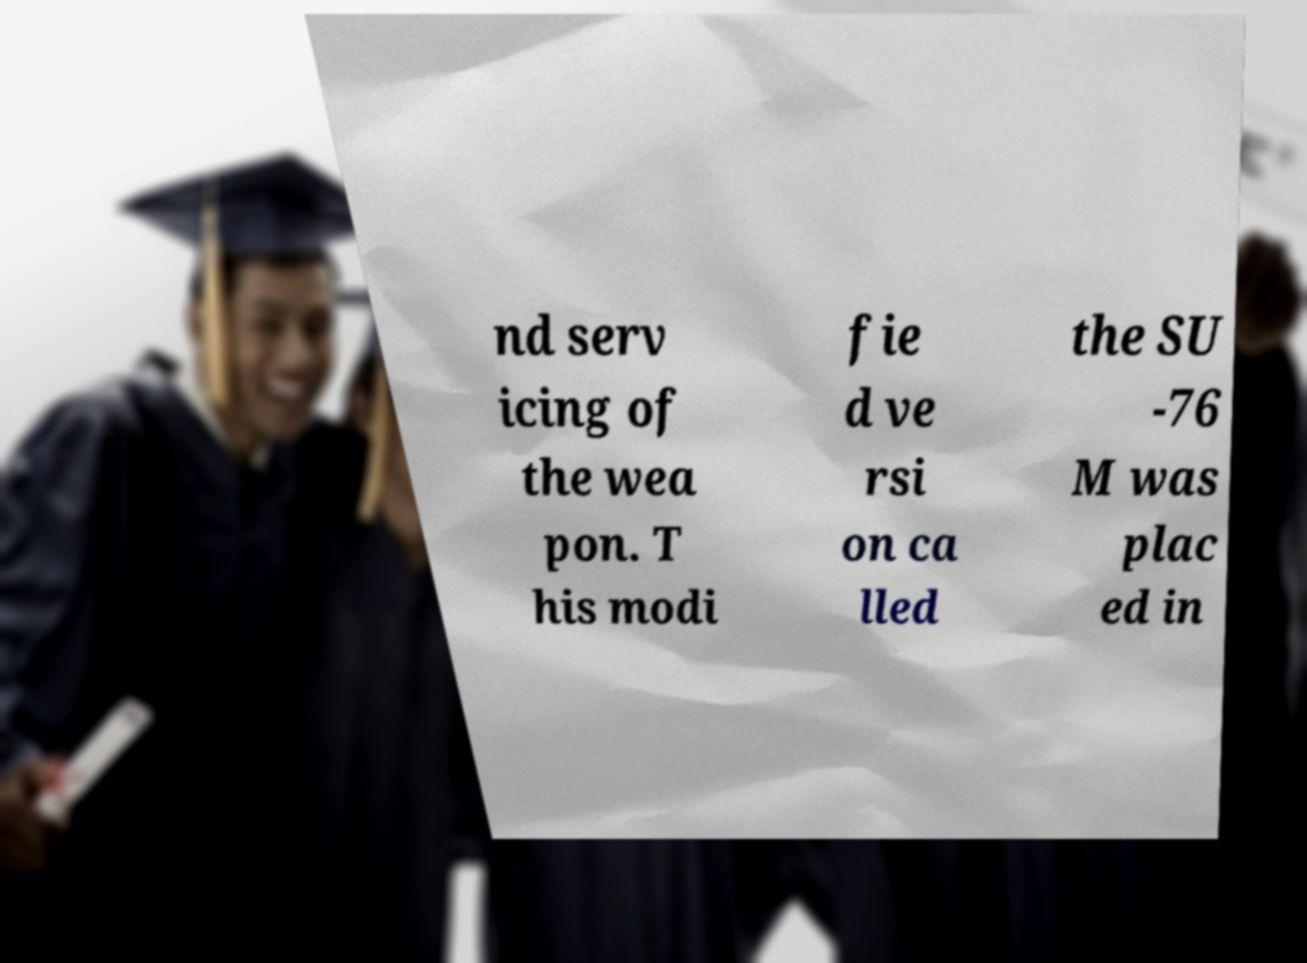I need the written content from this picture converted into text. Can you do that? nd serv icing of the wea pon. T his modi fie d ve rsi on ca lled the SU -76 M was plac ed in 